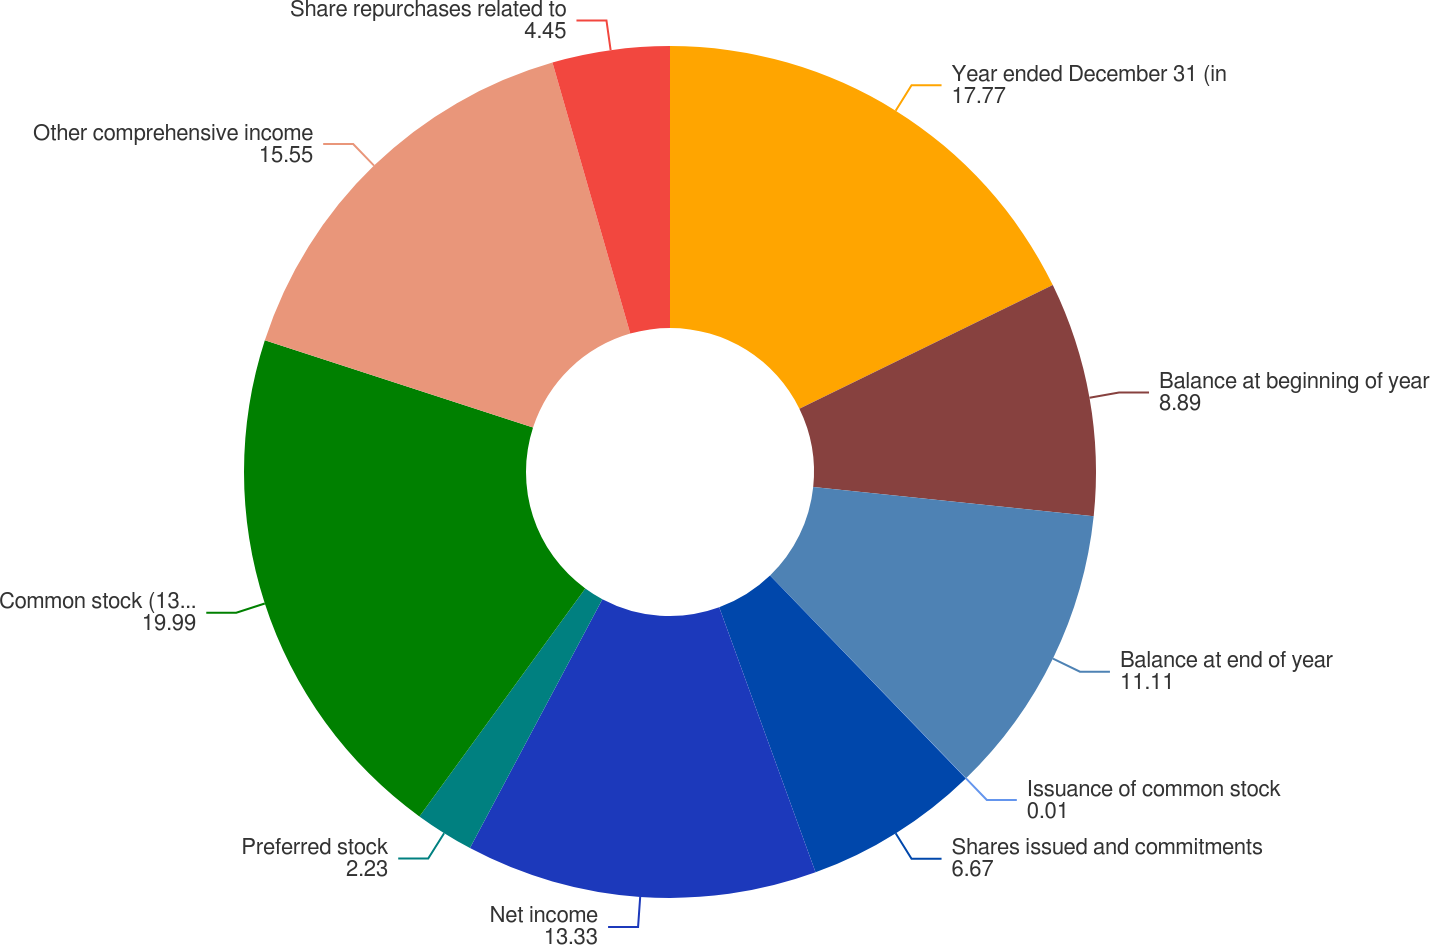Convert chart. <chart><loc_0><loc_0><loc_500><loc_500><pie_chart><fcel>Year ended December 31 (in<fcel>Balance at beginning of year<fcel>Balance at end of year<fcel>Issuance of common stock<fcel>Shares issued and commitments<fcel>Net income<fcel>Preferred stock<fcel>Common stock (136 per share<fcel>Other comprehensive income<fcel>Share repurchases related to<nl><fcel>17.77%<fcel>8.89%<fcel>11.11%<fcel>0.01%<fcel>6.67%<fcel>13.33%<fcel>2.23%<fcel>19.99%<fcel>15.55%<fcel>4.45%<nl></chart> 